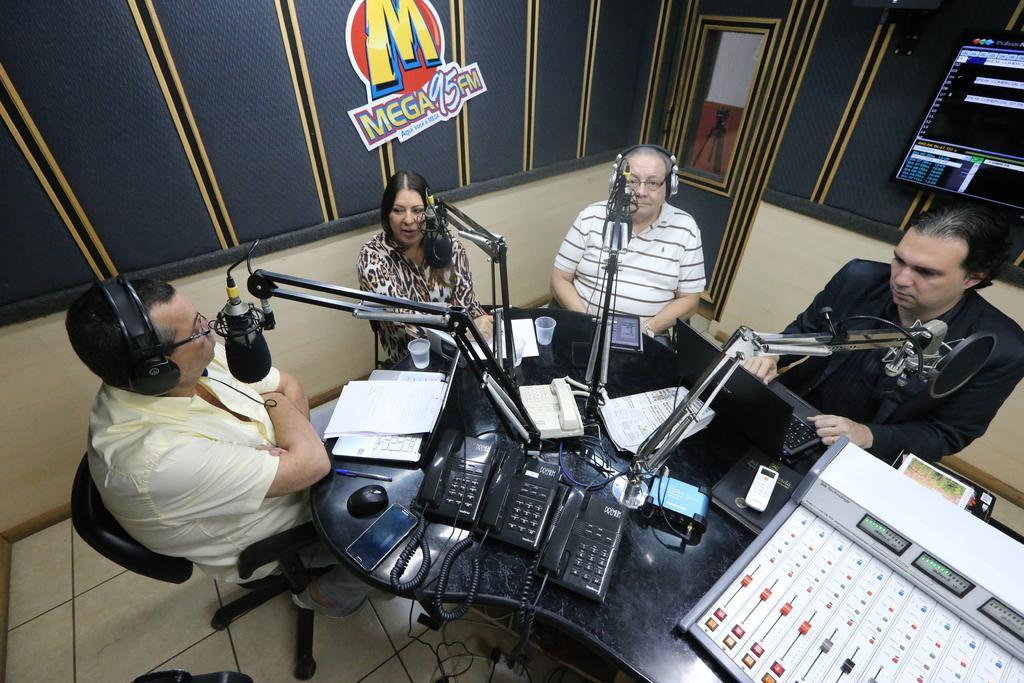Could you give a brief overview of what you see in this image? This picture shows few people seated on the chairs and we see couple of them wore headsets and we see microphones in front of them and few telephones and paper glasses and a mobile and we see mouse on the table and poster on the wall. We see a television and a sound controlling machine on the table. 